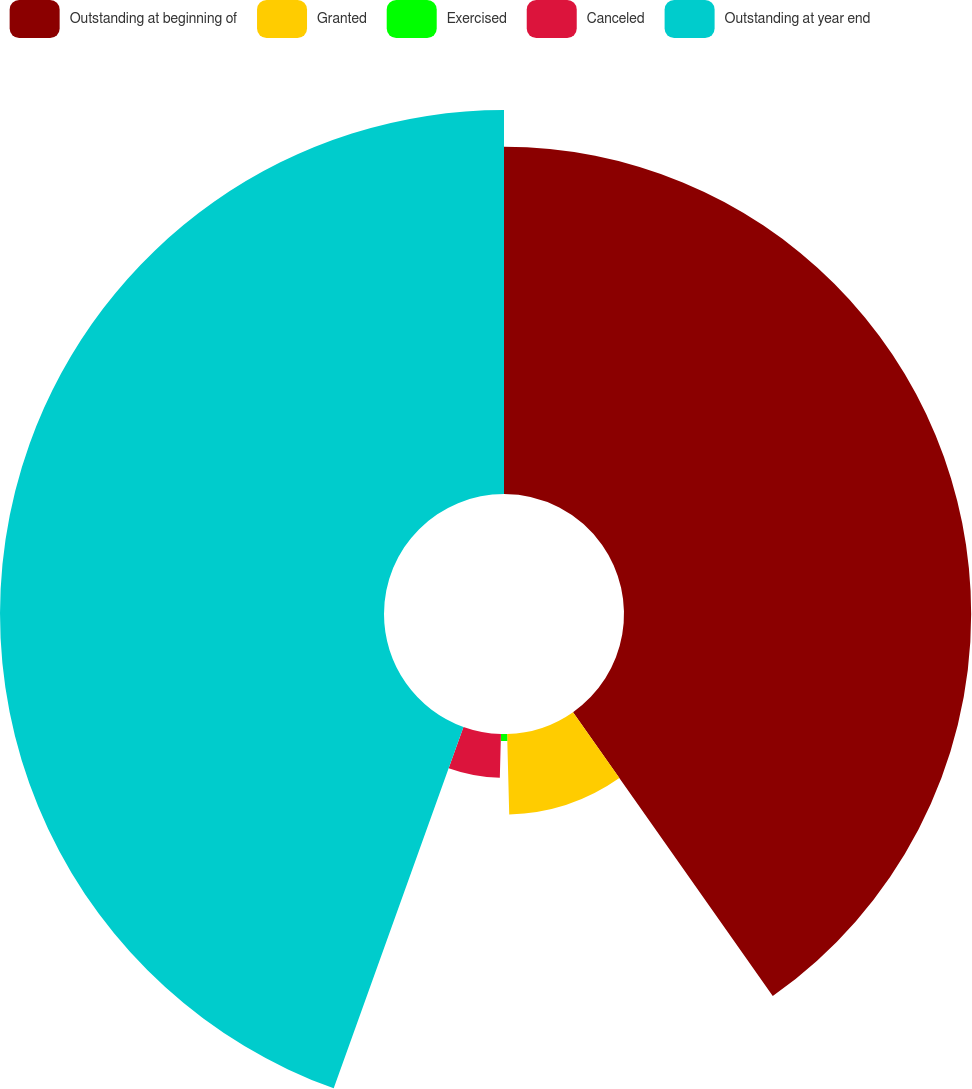<chart> <loc_0><loc_0><loc_500><loc_500><pie_chart><fcel>Outstanding at beginning of<fcel>Granted<fcel>Exercised<fcel>Canceled<fcel>Outstanding at year end<nl><fcel>40.24%<fcel>9.34%<fcel>0.82%<fcel>5.08%<fcel>44.51%<nl></chart> 